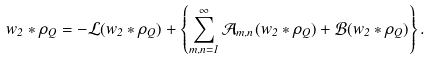Convert formula to latex. <formula><loc_0><loc_0><loc_500><loc_500>w _ { 2 } * \rho _ { Q } = - \mathcal { L } ( w _ { 2 } * \rho _ { Q } ) + \left \{ \sum _ { m , n = 1 } ^ { \infty } \mathcal { A } _ { m , n } ( w _ { 2 } * \rho _ { Q } ) + \mathcal { B } ( w _ { 2 } * \rho _ { Q } ) \right \} .</formula> 